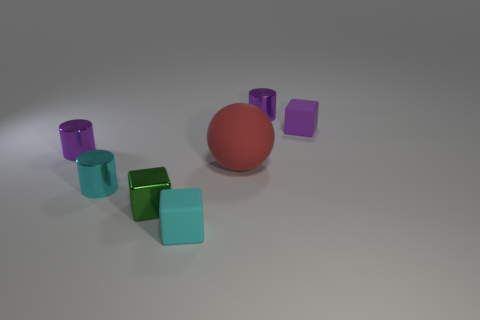There is a small purple thing that is right of the purple metallic thing that is right of the tiny green metallic object; is there a small metal cylinder behind it?
Keep it short and to the point. Yes. Is the material of the big ball the same as the cube that is to the right of the red ball?
Ensure brevity in your answer.  Yes. There is a tiny rubber cube that is right of the object in front of the green metallic thing; what color is it?
Your answer should be very brief. Purple. Is there a big ball that has the same color as the big matte thing?
Give a very brief answer. No. How big is the thing that is on the right side of the small metal object that is behind the tiny purple metal cylinder in front of the purple matte cube?
Your answer should be very brief. Small. Is the shape of the green thing the same as the small purple shiny thing on the right side of the cyan matte block?
Ensure brevity in your answer.  No. What number of other objects are there of the same size as the cyan matte object?
Your answer should be compact. 5. What is the size of the red ball that is on the right side of the green metallic cube?
Offer a terse response. Large. How many tiny cyan cylinders have the same material as the purple block?
Provide a short and direct response. 0. Is the shape of the tiny rubber thing that is in front of the ball the same as  the green metal thing?
Provide a succinct answer. Yes. 